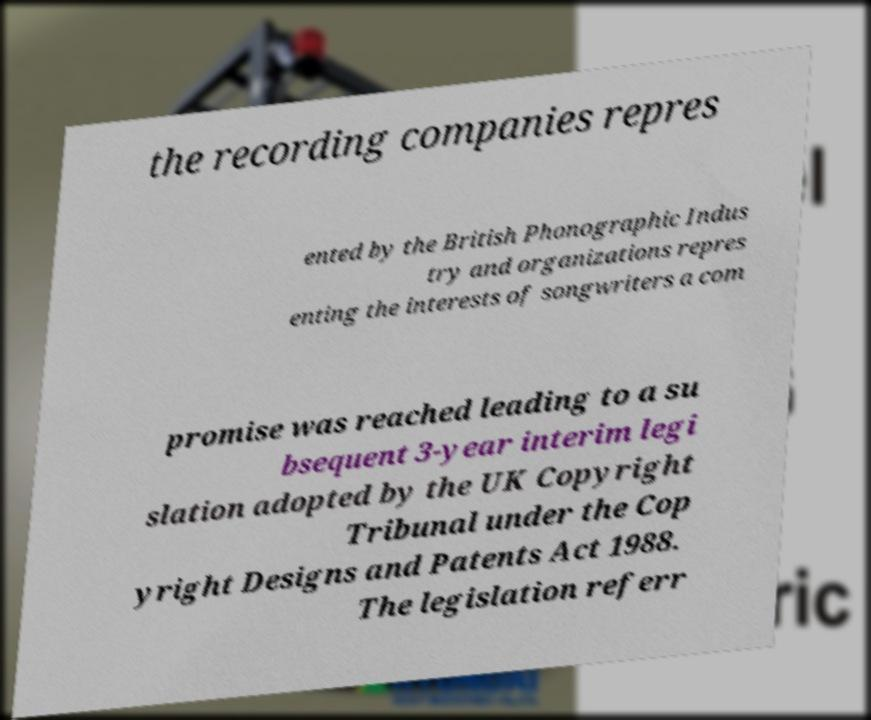For documentation purposes, I need the text within this image transcribed. Could you provide that? the recording companies repres ented by the British Phonographic Indus try and organizations repres enting the interests of songwriters a com promise was reached leading to a su bsequent 3-year interim legi slation adopted by the UK Copyright Tribunal under the Cop yright Designs and Patents Act 1988. The legislation referr 